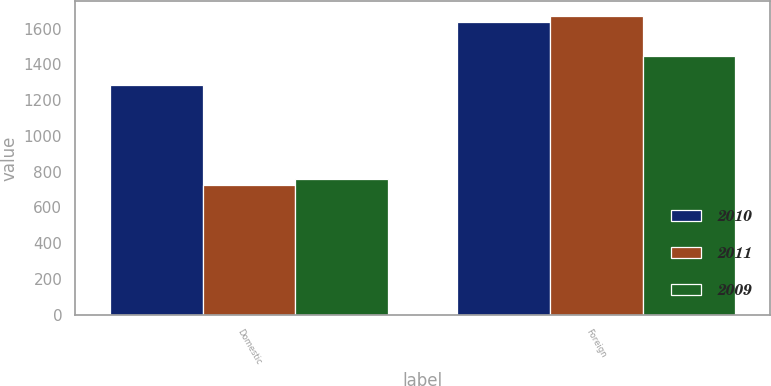Convert chart. <chart><loc_0><loc_0><loc_500><loc_500><stacked_bar_chart><ecel><fcel>Domestic<fcel>Foreign<nl><fcel>2010<fcel>1282<fcel>1640<nl><fcel>2011<fcel>727<fcel>1670<nl><fcel>2009<fcel>761<fcel>1447<nl></chart> 